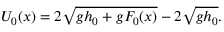Convert formula to latex. <formula><loc_0><loc_0><loc_500><loc_500>U _ { 0 } ( x ) = 2 \sqrt { g h _ { 0 } + g F _ { 0 } ( x ) } - 2 \sqrt { g h _ { 0 } } .</formula> 